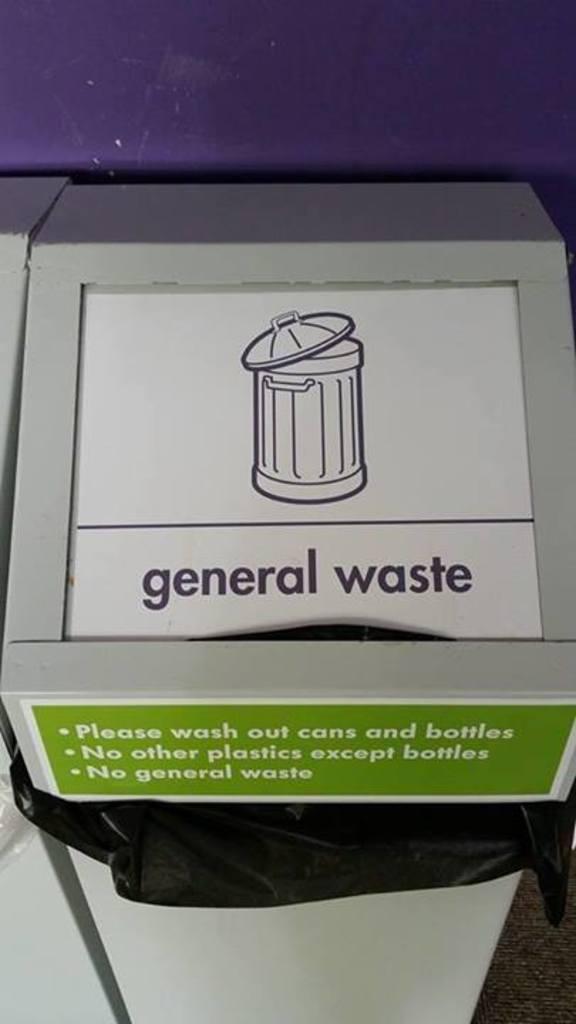Can you put general waste inside the bin?
Give a very brief answer. Yes. What do you need to do to cans and bottles?
Provide a succinct answer. Wash out. 